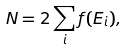Convert formula to latex. <formula><loc_0><loc_0><loc_500><loc_500>N = 2 \sum _ { i } f ( E _ { i } ) ,</formula> 